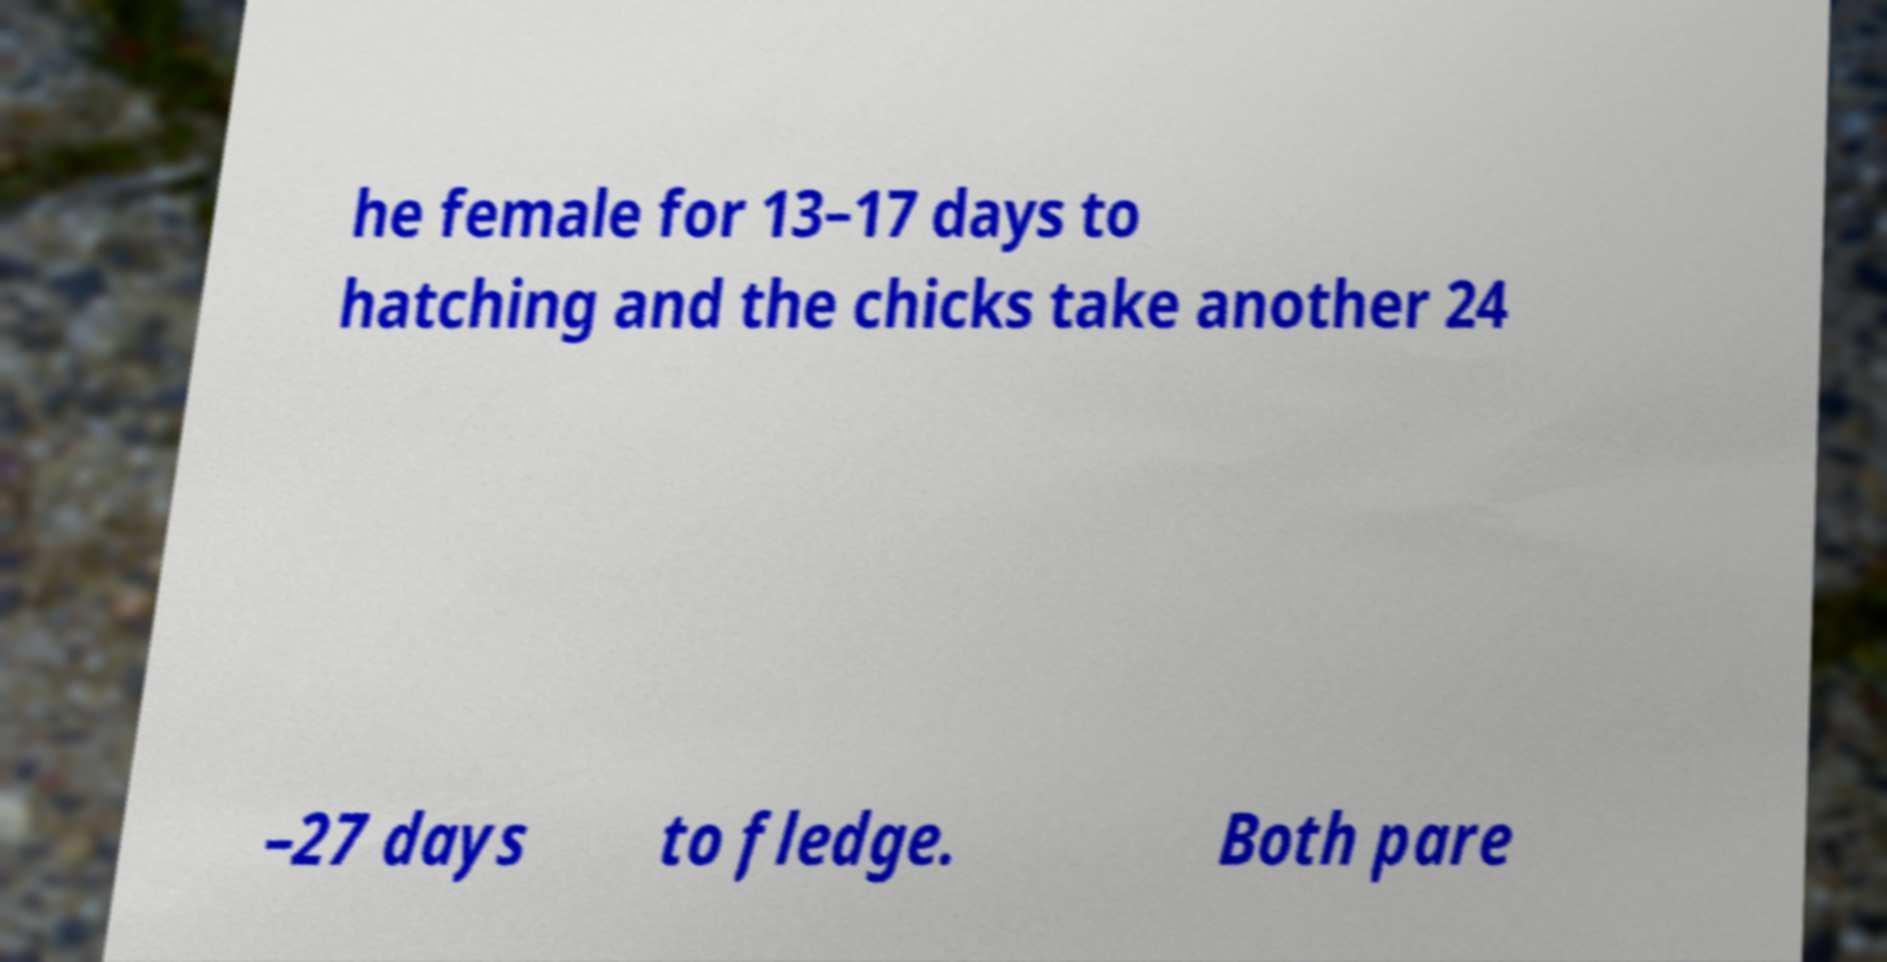Please read and relay the text visible in this image. What does it say? he female for 13–17 days to hatching and the chicks take another 24 –27 days to fledge. Both pare 